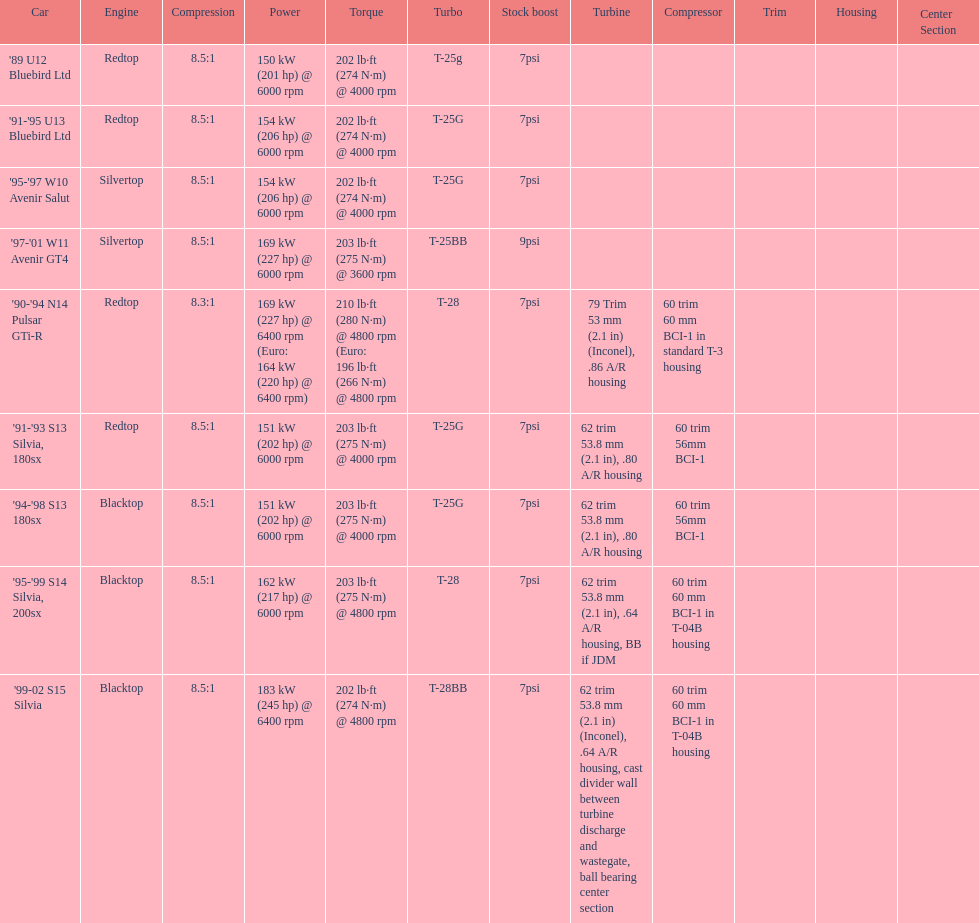Which engine has the smallest compression rate? '90-'94 N14 Pulsar GTi-R. 